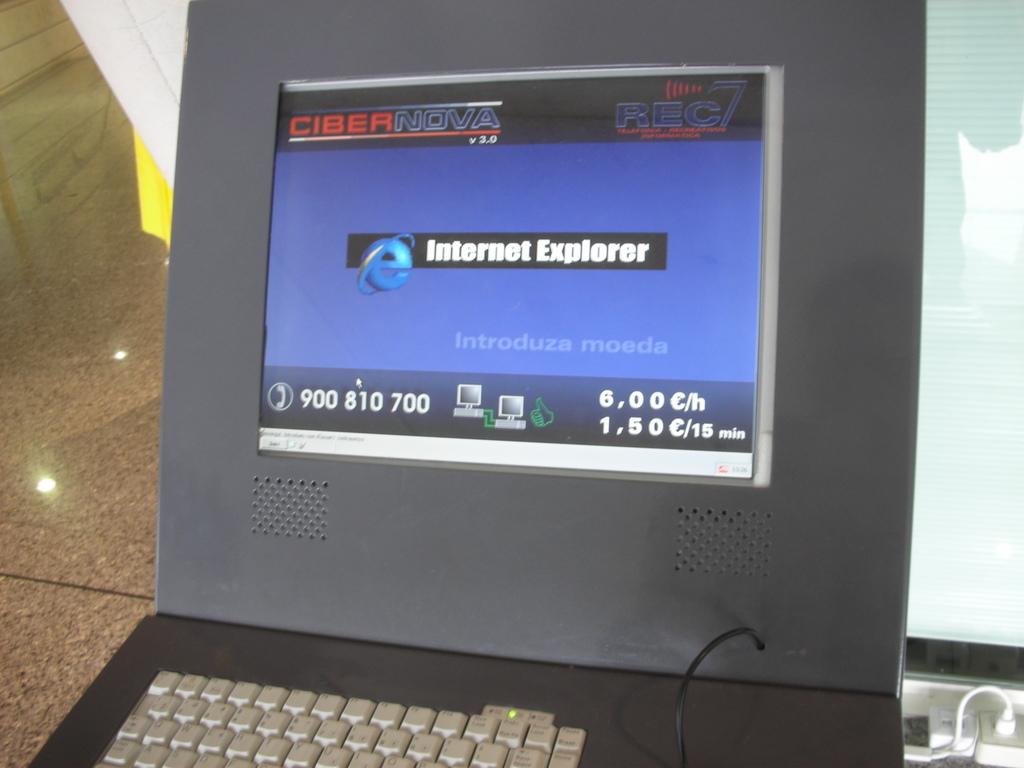What web browser does the computer use?
Ensure brevity in your answer.  Internet explorer. What brand is this internet service provider?
Provide a succinct answer. Cibernova. 